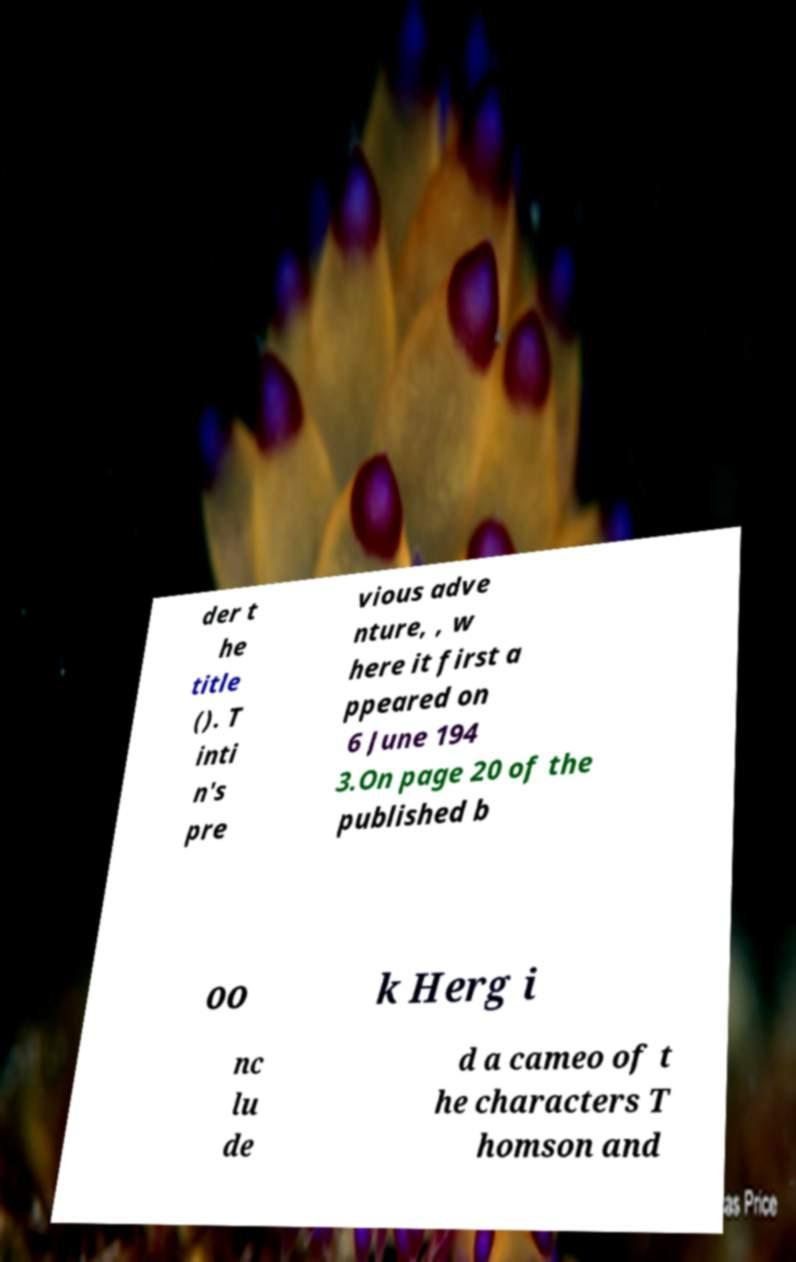What messages or text are displayed in this image? I need them in a readable, typed format. der t he title (). T inti n's pre vious adve nture, , w here it first a ppeared on 6 June 194 3.On page 20 of the published b oo k Herg i nc lu de d a cameo of t he characters T homson and 